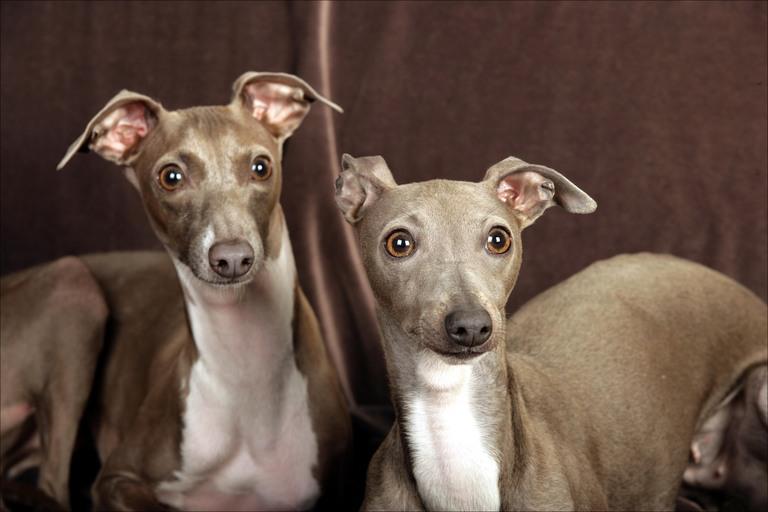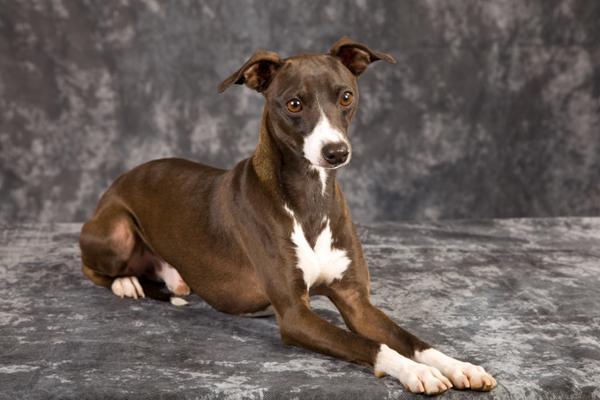The first image is the image on the left, the second image is the image on the right. Given the left and right images, does the statement "In one image, are two dogs facing towards the camera." hold true? Answer yes or no. Yes. The first image is the image on the left, the second image is the image on the right. Considering the images on both sides, is "All of the dogs are outside and none of them is wearing a collar." valid? Answer yes or no. No. 